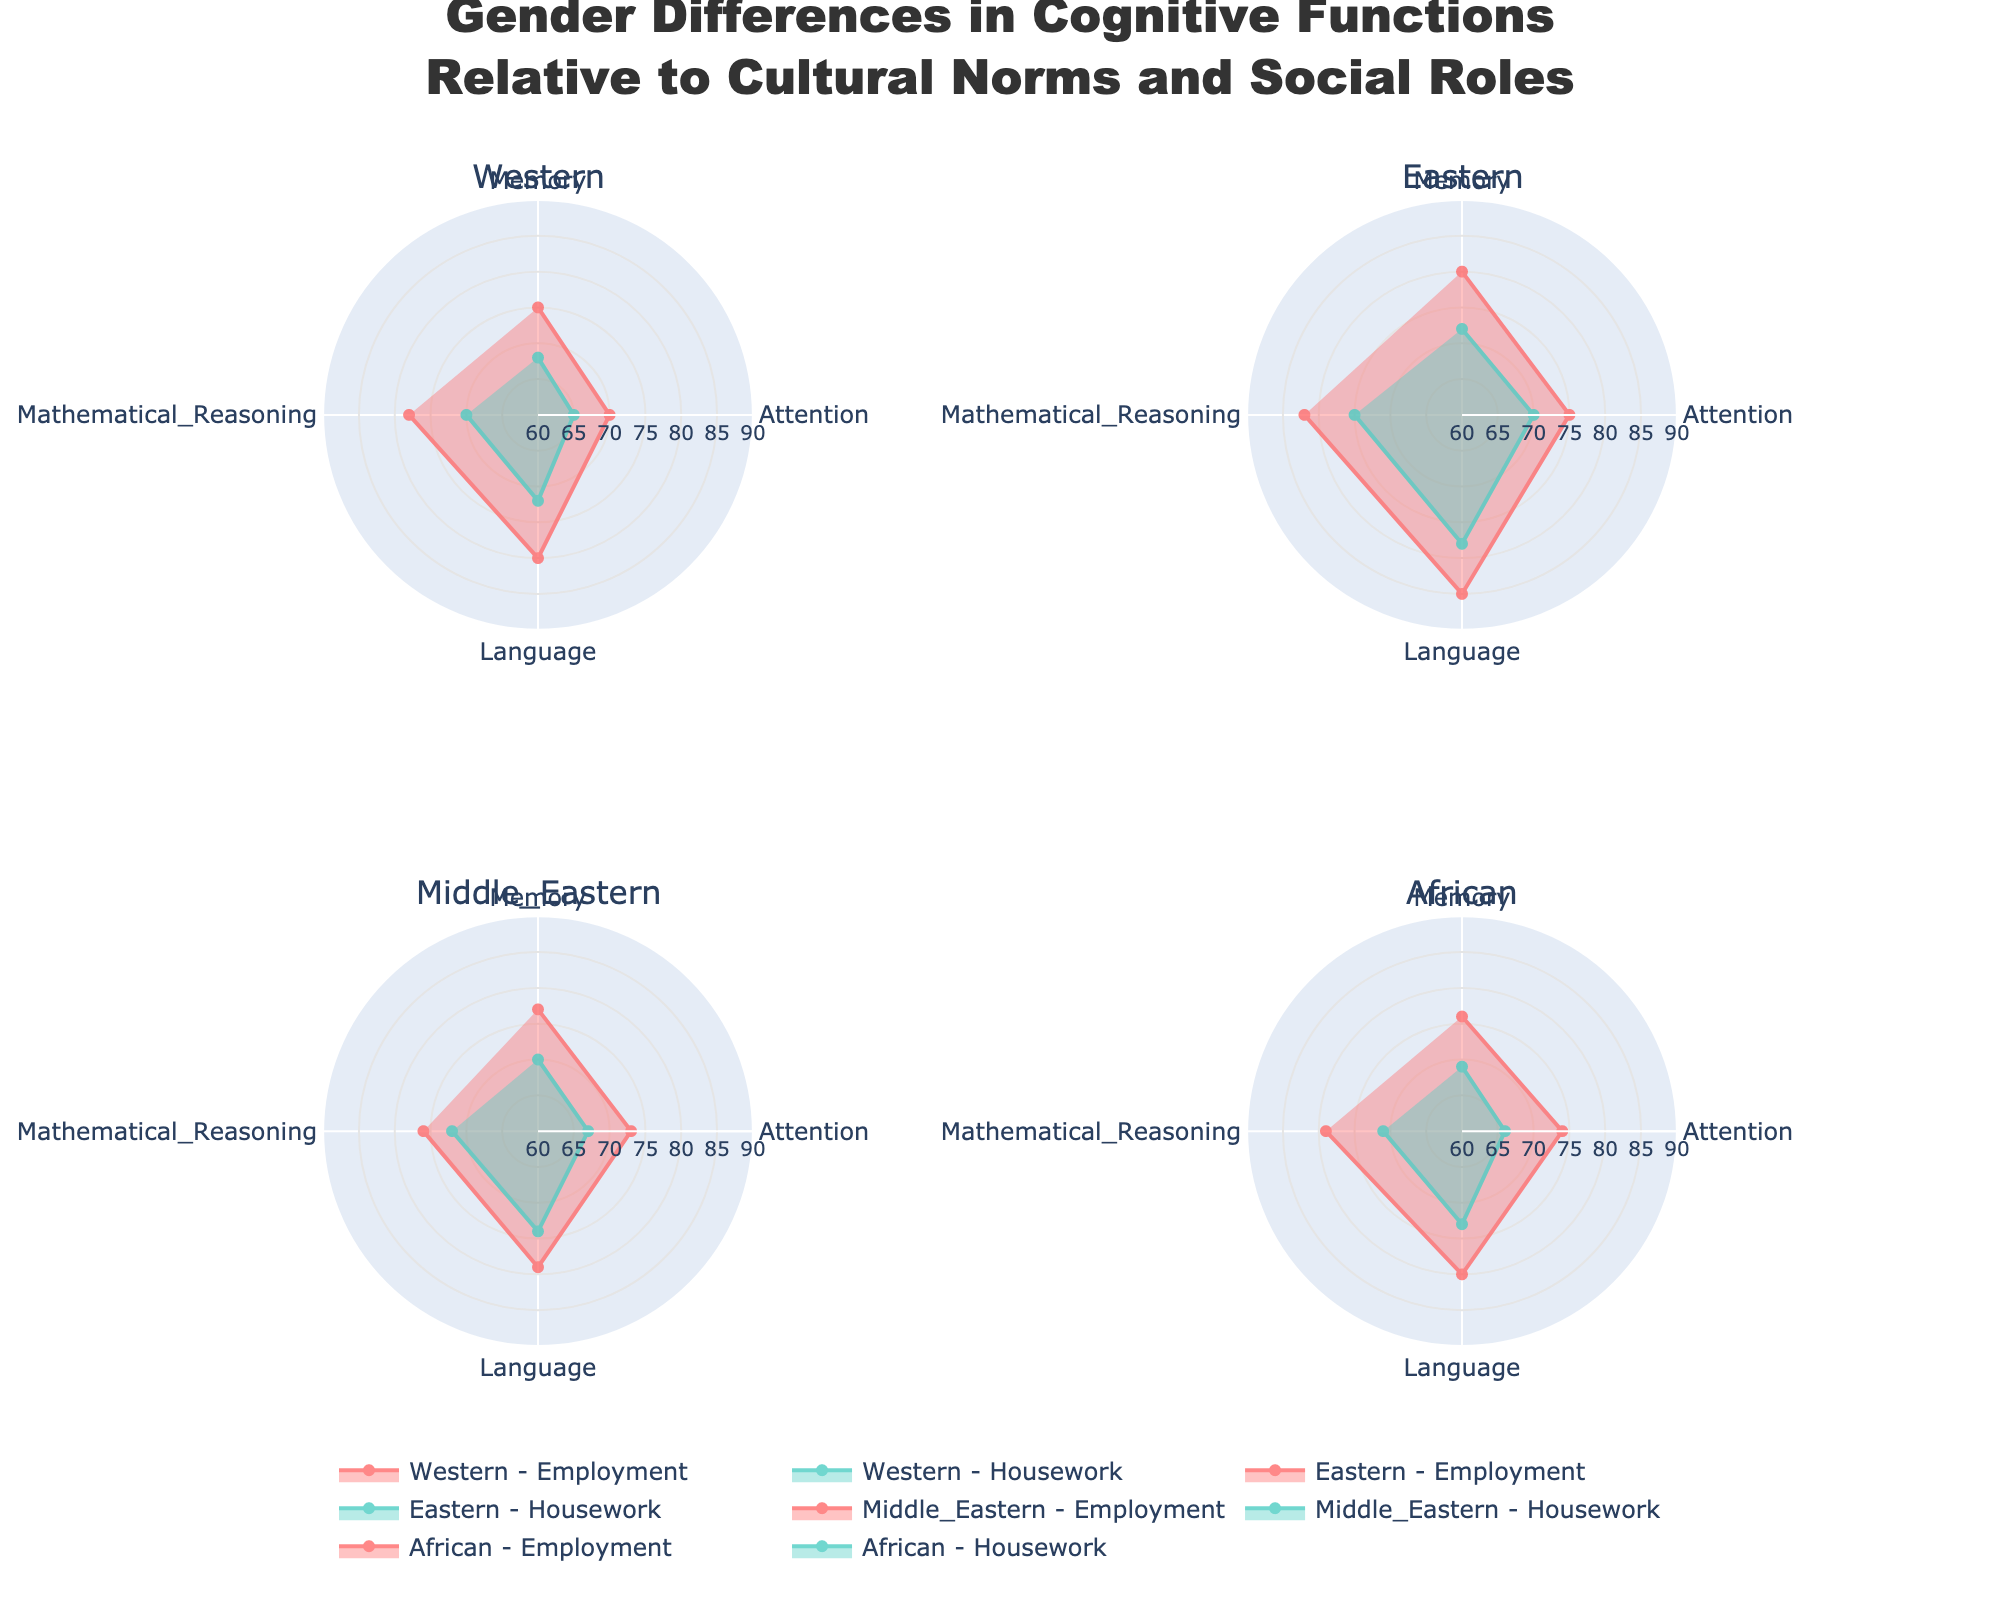What is the title of the figure? The title is usually listed at the top of the figure. It provides a summary of what the figure represents. The title of the figure is "Gender Differences in Cognitive Functions Relative to Cultural Norms and Social Roles".
Answer: Gender Differences in Cognitive Functions Relative to Cultural Norms and Social Roles What are the cultures represented in the figure? The subplot titles correspond to different cultures represented in the figure. Here, the cultures are "Western," "Eastern," "Middle Eastern," and "African".
Answer: Western, Eastern, Middle Eastern, African Which cognitive function has the highest score for Eastern Employment? To find the highest score, we look at the scores for all cognitive functions under Eastern Employment in the respective polar chart. Language has the score of 85, which is the highest.
Answer: Language For Western Housework, which cognitive function shows the lowest score and what is it? By examining the polar chart for Western Housework, we find that Attention has the lowest score of 65.
Answer: Attention, 65 What is the average Memory score for Middle Eastern Employment and Housework combined? To find this, add the scores for Memory under Middle Eastern Employment and Housework, then divide by 2. The scores are 77 (Employment) and 70 (Housework), so (77 + 70) / 2 = 73.5.
Answer: 73.5 Is Attention score higher for African Housework or Middle Eastern Housework? The polar charts show that the Attention score is 66 for African Housework and 67 for Middle Eastern Housework, thus, it is higher for Middle Eastern Housework.
Answer: Middle Eastern Housework Which social role has a higher average score across all cognitive functions for Western culture? Calculate the average scores for each role in Western culture. Employment scores: (75 + 70 + 80 + 78) / 4 = 75.75. Housework scores: (68 + 65 + 72 + 70) / 4 = 68.75. Compare the results: Employment has a higher average.
Answer: Employment How does the average Mathematical Reasoning score of African Employment compare with Eastern Employment? Calculate the average score for Mathematical Reasoning in both African Employment (79) and Eastern Employment (82). Compare the scores: Eastern Employment is higher by 3.
Answer: Eastern Employment is higher What are the ranges of scores shown on the radial axis? The radial axis shows the range of scores typically from 60 to 90, based on the provided figure layout configuration and visible tick marks.
Answer: 60 to 90 